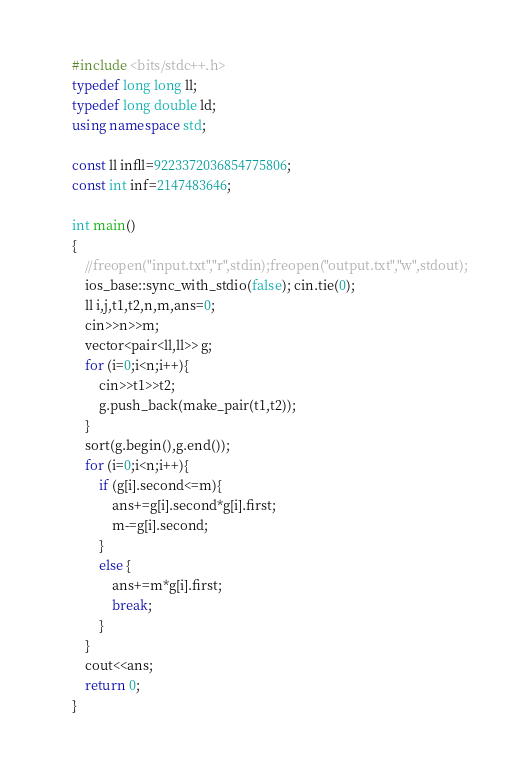<code> <loc_0><loc_0><loc_500><loc_500><_C++_>#include <bits/stdc++.h>
typedef long long ll;
typedef long double ld;
using namespace std;

const ll infll=9223372036854775806;
const int inf=2147483646;

int main()
{
	//freopen("input.txt","r",stdin);freopen("output.txt","w",stdout);
	ios_base::sync_with_stdio(false); cin.tie(0);
	ll i,j,t1,t2,n,m,ans=0;
	cin>>n>>m;
	vector<pair<ll,ll>> g;
	for (i=0;i<n;i++){
		cin>>t1>>t2;
		g.push_back(make_pair(t1,t2));
	}
	sort(g.begin(),g.end());
	for (i=0;i<n;i++){
		if (g[i].second<=m){
			ans+=g[i].second*g[i].first;
			m-=g[i].second;
		}
		else {
			ans+=m*g[i].first;
			break;
		}
	}
	cout<<ans;
	return 0;
}</code> 